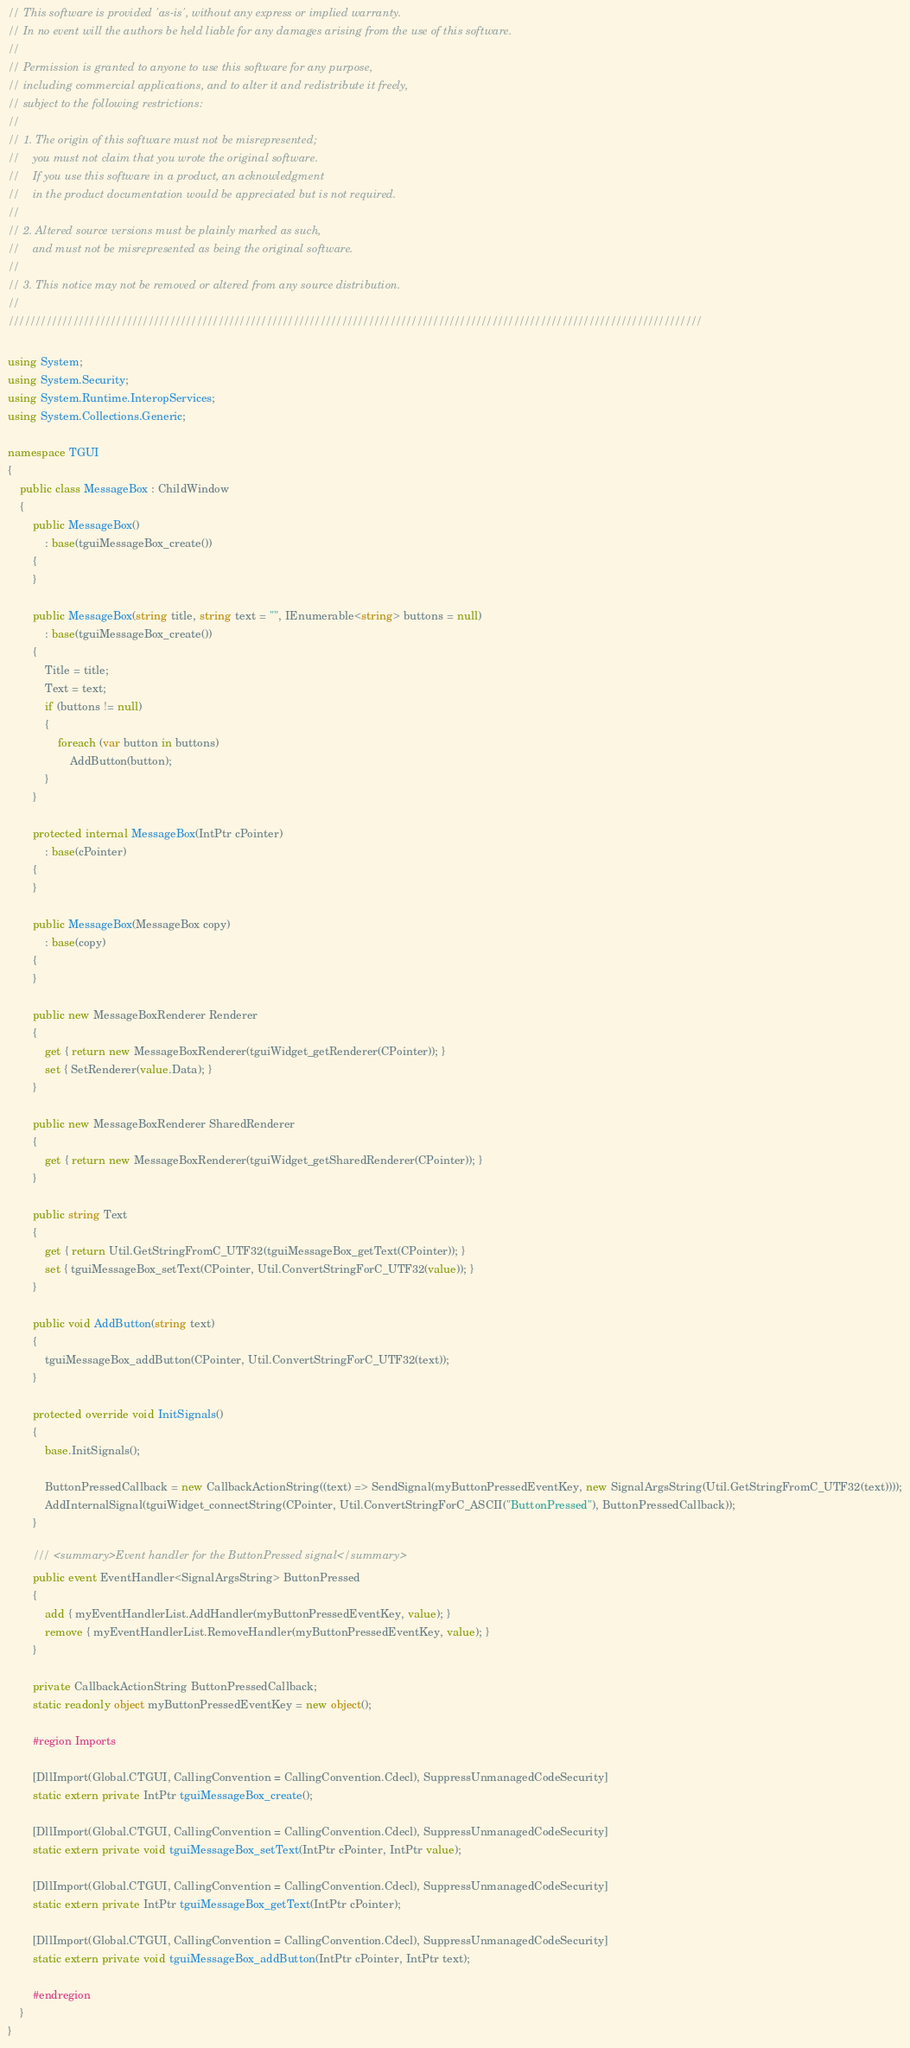<code> <loc_0><loc_0><loc_500><loc_500><_C#_>// This software is provided 'as-is', without any express or implied warranty.
// In no event will the authors be held liable for any damages arising from the use of this software.
//
// Permission is granted to anyone to use this software for any purpose,
// including commercial applications, and to alter it and redistribute it freely,
// subject to the following restrictions:
//
// 1. The origin of this software must not be misrepresented;
//    you must not claim that you wrote the original software.
//    If you use this software in a product, an acknowledgment
//    in the product documentation would be appreciated but is not required.
//
// 2. Altered source versions must be plainly marked as such,
//    and must not be misrepresented as being the original software.
//
// 3. This notice may not be removed or altered from any source distribution.
//
/////////////////////////////////////////////////////////////////////////////////////////////////////////////////////////////////

using System;
using System.Security;
using System.Runtime.InteropServices;
using System.Collections.Generic;

namespace TGUI
{
    public class MessageBox : ChildWindow
    {
        public MessageBox()
            : base(tguiMessageBox_create())
        {
        }

        public MessageBox(string title, string text = "", IEnumerable<string> buttons = null)
            : base(tguiMessageBox_create())
        {
            Title = title;
            Text = text;
            if (buttons != null)
            {
                foreach (var button in buttons)
                    AddButton(button);
            }
        }

        protected internal MessageBox(IntPtr cPointer)
            : base(cPointer)
        {
        }

        public MessageBox(MessageBox copy)
            : base(copy)
        {
        }

        public new MessageBoxRenderer Renderer
        {
            get { return new MessageBoxRenderer(tguiWidget_getRenderer(CPointer)); }
            set { SetRenderer(value.Data); }
        }

        public new MessageBoxRenderer SharedRenderer
        {
            get { return new MessageBoxRenderer(tguiWidget_getSharedRenderer(CPointer)); }
        }

        public string Text
        {
            get { return Util.GetStringFromC_UTF32(tguiMessageBox_getText(CPointer)); }
            set { tguiMessageBox_setText(CPointer, Util.ConvertStringForC_UTF32(value)); }
        }

        public void AddButton(string text)
        {
            tguiMessageBox_addButton(CPointer, Util.ConvertStringForC_UTF32(text));
        }

        protected override void InitSignals()
        {
            base.InitSignals();

            ButtonPressedCallback = new CallbackActionString((text) => SendSignal(myButtonPressedEventKey, new SignalArgsString(Util.GetStringFromC_UTF32(text))));
            AddInternalSignal(tguiWidget_connectString(CPointer, Util.ConvertStringForC_ASCII("ButtonPressed"), ButtonPressedCallback));
        }

        /// <summary>Event handler for the ButtonPressed signal</summary>
        public event EventHandler<SignalArgsString> ButtonPressed
        {
            add { myEventHandlerList.AddHandler(myButtonPressedEventKey, value); }
            remove { myEventHandlerList.RemoveHandler(myButtonPressedEventKey, value); }
        }

        private CallbackActionString ButtonPressedCallback;
        static readonly object myButtonPressedEventKey = new object();

        #region Imports

        [DllImport(Global.CTGUI, CallingConvention = CallingConvention.Cdecl), SuppressUnmanagedCodeSecurity]
        static extern private IntPtr tguiMessageBox_create();

        [DllImport(Global.CTGUI, CallingConvention = CallingConvention.Cdecl), SuppressUnmanagedCodeSecurity]
        static extern private void tguiMessageBox_setText(IntPtr cPointer, IntPtr value);

        [DllImport(Global.CTGUI, CallingConvention = CallingConvention.Cdecl), SuppressUnmanagedCodeSecurity]
        static extern private IntPtr tguiMessageBox_getText(IntPtr cPointer);

        [DllImport(Global.CTGUI, CallingConvention = CallingConvention.Cdecl), SuppressUnmanagedCodeSecurity]
        static extern private void tguiMessageBox_addButton(IntPtr cPointer, IntPtr text);

        #endregion
    }
}
</code> 